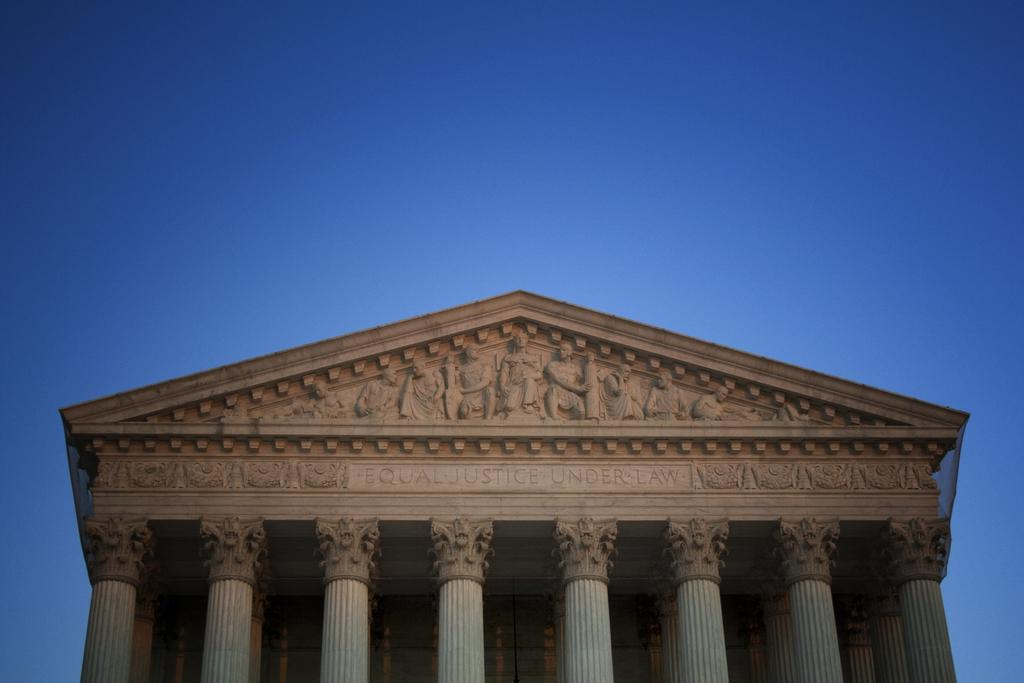What type of objects are on the wall in the image? There are statues on the wall in the image. What architectural features can be seen in the image? There are pillars in the image. What is visible in the background of the image? The sky is visible in the background of the image. What is the color of the sky in the image? The color of the sky is blue. Where is the pear located in the image? There is no pear present in the image. What type of stone is used to construct the pillars in the image? The provided facts do not mention the type of stone used for the pillars, so we cannot determine that information from the image. 